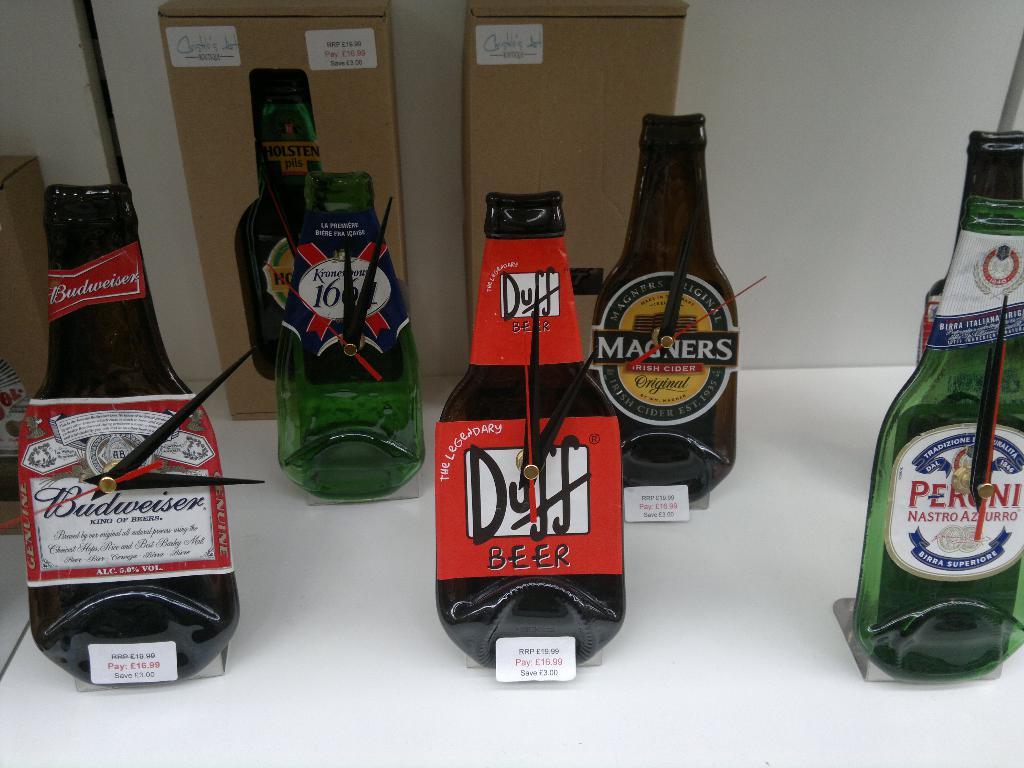What is the name of the beer in the middle in the front?
Provide a succinct answer. Duff. What is written on the beer on the left?
Provide a succinct answer. Budweiser. 